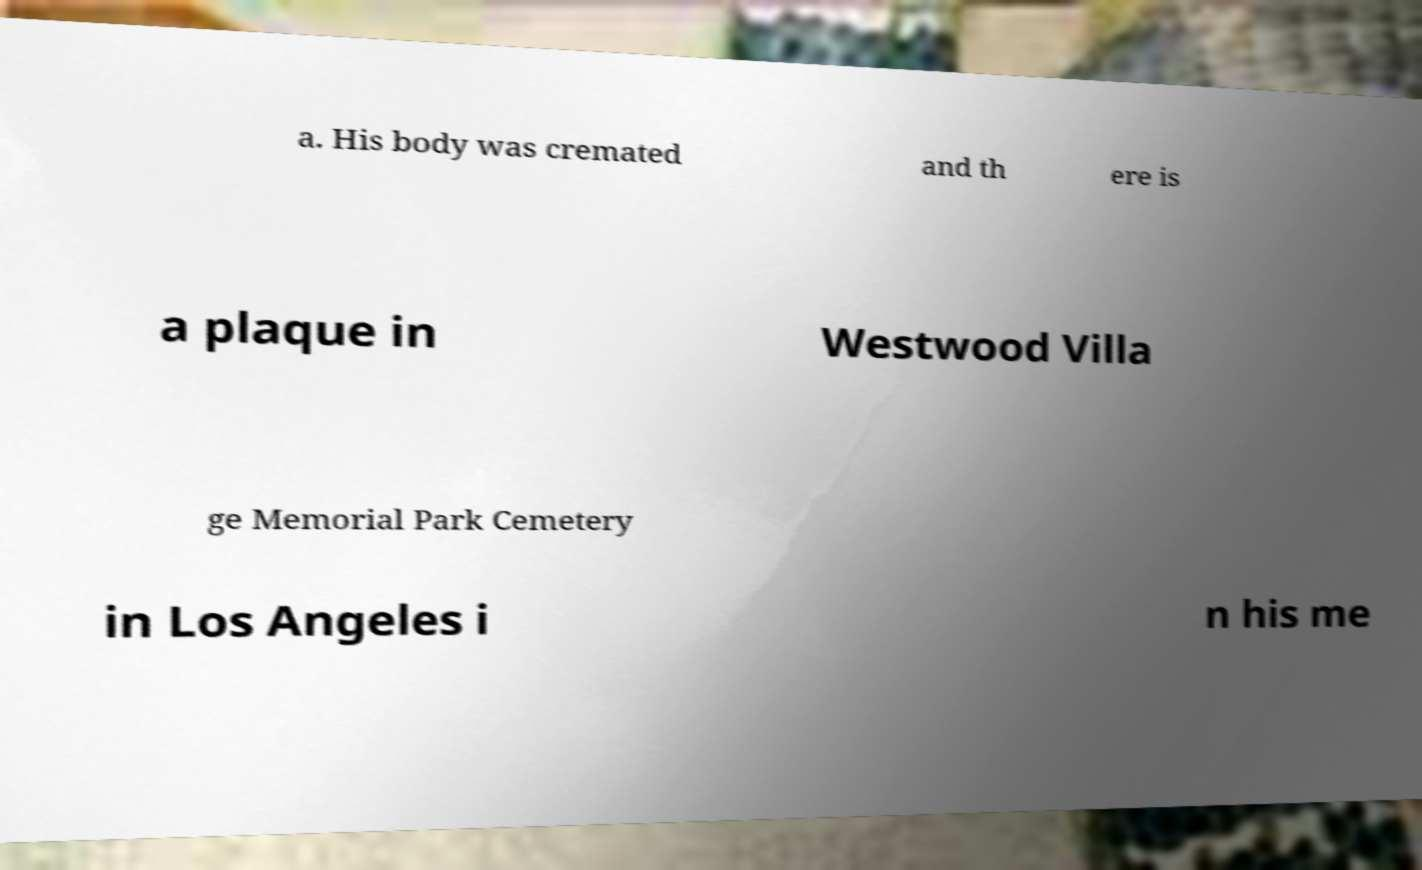What messages or text are displayed in this image? I need them in a readable, typed format. a. His body was cremated and th ere is a plaque in Westwood Villa ge Memorial Park Cemetery in Los Angeles i n his me 